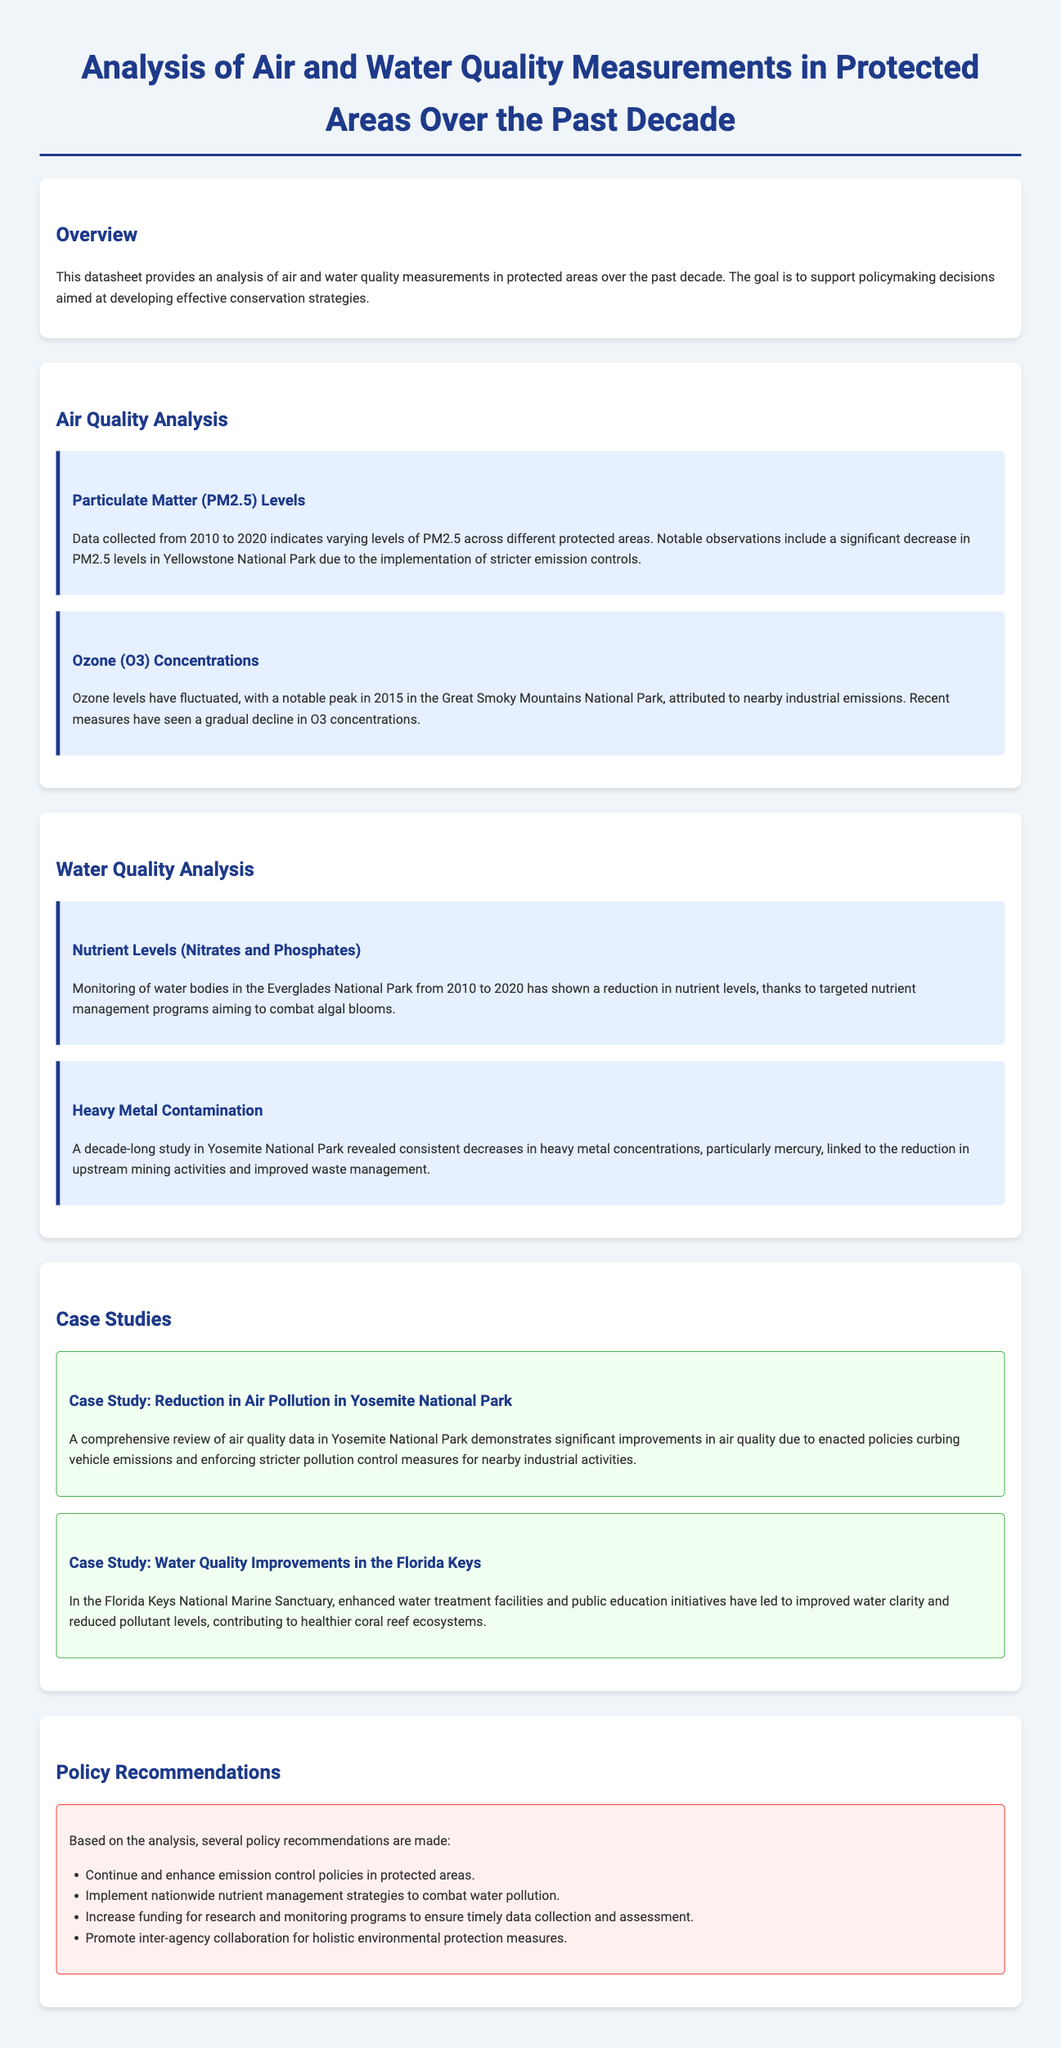what is the main subject of the datasheet? The datasheet provides an analysis of air and water quality measurements in protected areas over the past decade.
Answer: air and water quality measurements which national park saw a significant decrease in PM2.5 levels? The document states that Yellowstone National Park experienced a significant decrease in PM2.5 levels due to stricter emission controls.
Answer: Yellowstone National Park what year had a notable peak in ozone levels in the Great Smoky Mountains? The datasheet indicates that the ozone levels peaked in 2015 in the Great Smoky Mountains National Park.
Answer: 2015 what type of water quality issue was addressed in the Everglades National Park? The document mentions a reduction in nutrient levels, specifically nitrates and phosphates, in the Everglades National Park.
Answer: nutrient levels which case study references improvements in water quality in coral reef ecosystems? The document cites a case study regarding improved water clarity and reduced pollutant levels in the Florida Keys National Marine Sanctuary, contributing to healthier coral reef ecosystems.
Answer: Florida Keys National Marine Sanctuary what is one of the policy recommendations provided in the datasheet? The datasheet lists several recommendations, one being to implement nationwide nutrient management strategies to combat water pollution.
Answer: implement nationwide nutrient management strategies which pollutant showed consistent decreases in Yosemite National Park? The datasheet states that heavy metal concentrations, particularly mercury, showed consistent decreases in Yosemite National Park.
Answer: mercury what management strategy contributed to reduced nutrient levels in the Everglades? The analysis credited targeted nutrient management programs as key in combating algal blooms in the Everglades National Park.
Answer: targeted nutrient management programs 